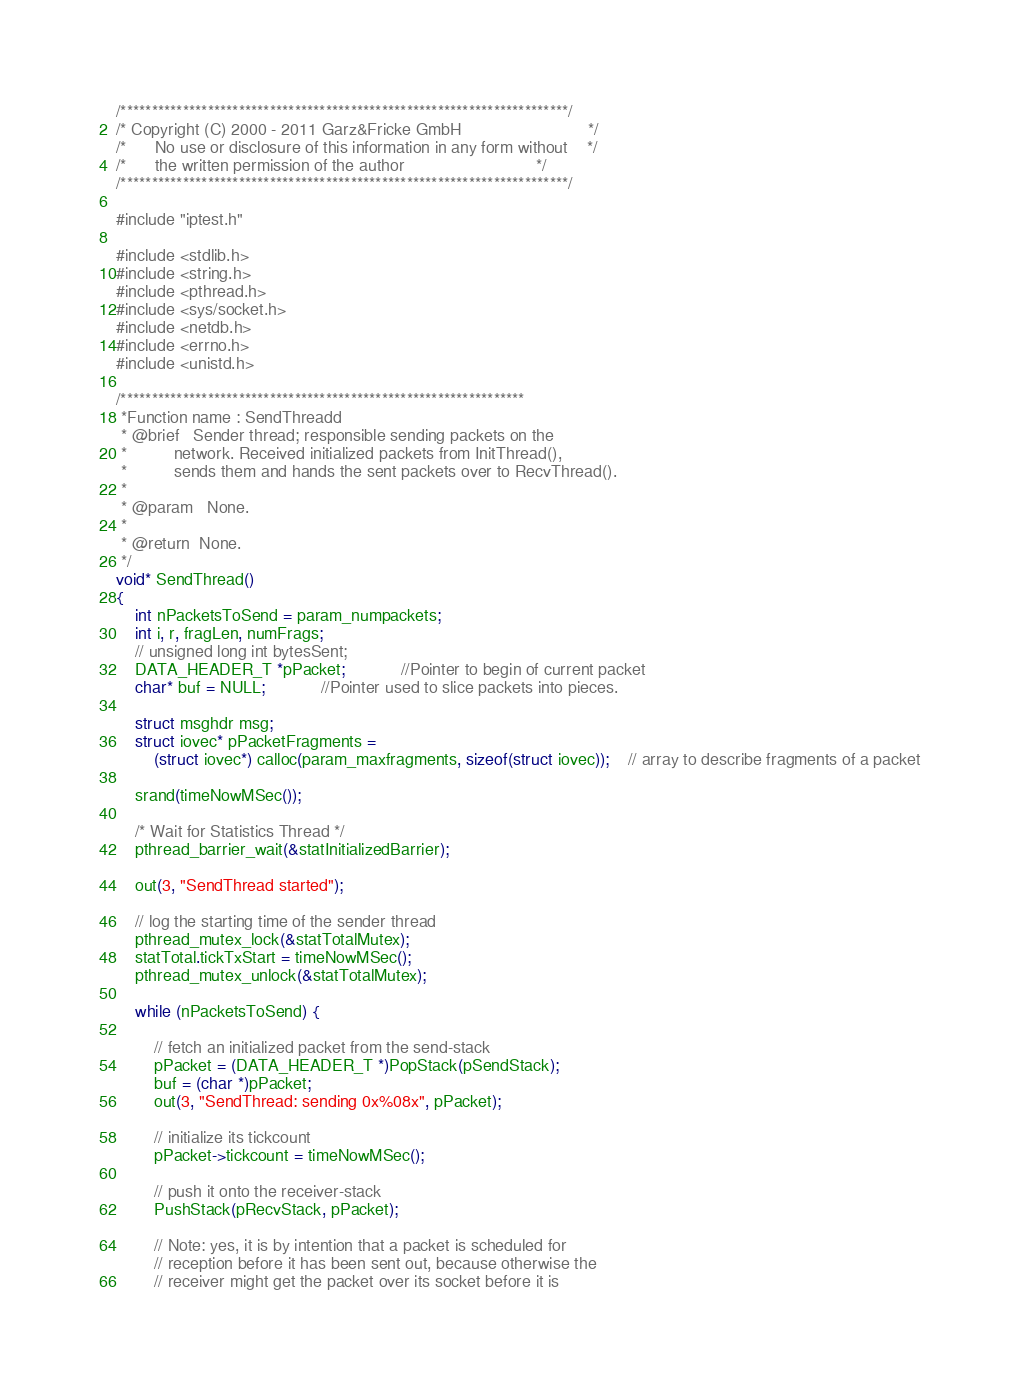Convert code to text. <code><loc_0><loc_0><loc_500><loc_500><_C_>/************************************************************************/
/* Copyright (C) 2000 - 2011 Garz&Fricke GmbH							*/
/*		No use or disclosure of this information in any form without	*/
/*		the written permission of the author							*/
/************************************************************************/

#include "iptest.h"

#include <stdlib.h>
#include <string.h>
#include <pthread.h>
#include <sys/socket.h>
#include <netdb.h>
#include <errno.h>
#include <unistd.h>

/*****************************************************************
 *Function name	: SendThreadd
 * @brief	Sender thread; responsible sending packets on the
 *			network. Received initialized packets from InitThread(),
 *			sends them and hands the sent packets over to RecvThread().
 *
 * @param	None.
 *
 * @return	None.
 */
void* SendThread()
{
	int nPacketsToSend = param_numpackets;
	int i, r, fragLen, numFrags;
	// unsigned long int bytesSent;
	DATA_HEADER_T *pPacket;			//Pointer to begin of current packet
	char* buf = NULL;			//Pointer used to slice packets into pieces.

	struct msghdr msg;
	struct iovec* pPacketFragments = 
		(struct iovec*) calloc(param_maxfragments, sizeof(struct iovec));	// array to describe fragments of a packet

	srand(timeNowMSec());

	/* Wait for Statistics Thread */
	pthread_barrier_wait(&statInitializedBarrier);

	out(3, "SendThread started");

	// log the starting time of the sender thread
	pthread_mutex_lock(&statTotalMutex);
	statTotal.tickTxStart = timeNowMSec(); 
	pthread_mutex_unlock(&statTotalMutex);
	
	while (nPacketsToSend) {

		// fetch an initialized packet from the send-stack
		pPacket = (DATA_HEADER_T *)PopStack(pSendStack);
		buf = (char *)pPacket;
		out(3, "SendThread: sending 0x%08x", pPacket);

		// initialize its tickcount
		pPacket->tickcount = timeNowMSec(); 

		// push it onto the receiver-stack
		PushStack(pRecvStack, pPacket);

		// Note: yes, it is by intention that a packet is scheduled for
		// reception before it has been sent out, because otherwise the
		// receiver might get the packet over its socket before it is</code> 